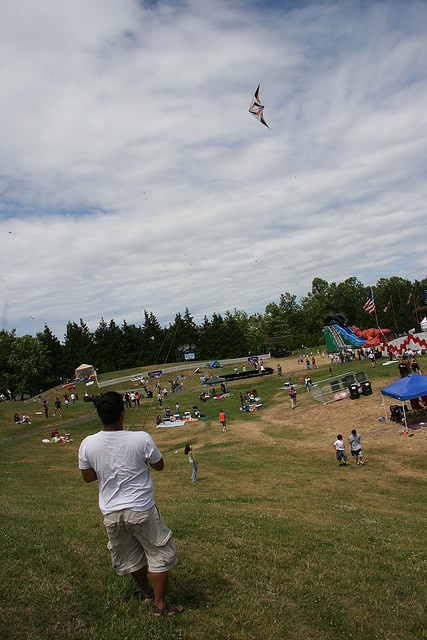Describe the objects in this image and their specific colors. I can see people in darkgray, darkgreen, black, gray, and maroon tones, people in darkgray, black, gray, and lightgray tones, people in darkgray, black, gray, and olive tones, kite in darkgray, black, and brown tones, and people in darkgray, black, gray, and olive tones in this image. 